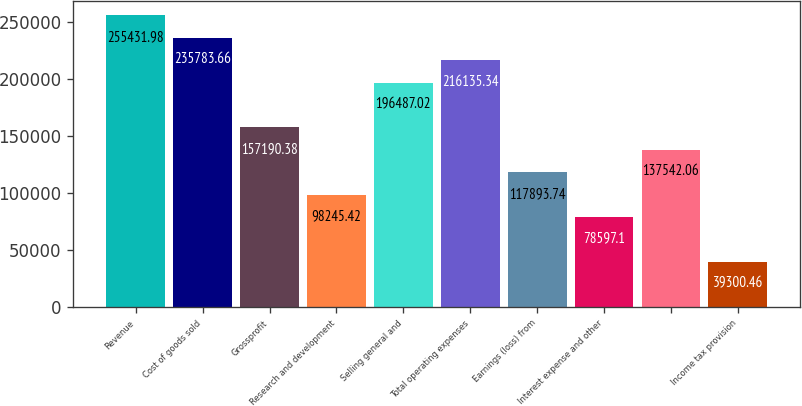<chart> <loc_0><loc_0><loc_500><loc_500><bar_chart><fcel>Revenue<fcel>Cost of goods sold<fcel>Grossprofit<fcel>Research and development<fcel>Selling general and<fcel>Total operating expenses<fcel>Earnings (loss) from<fcel>Interest expense and other<fcel>Unnamed: 8<fcel>Income tax provision<nl><fcel>255432<fcel>235784<fcel>157190<fcel>98245.4<fcel>196487<fcel>216135<fcel>117894<fcel>78597.1<fcel>137542<fcel>39300.5<nl></chart> 